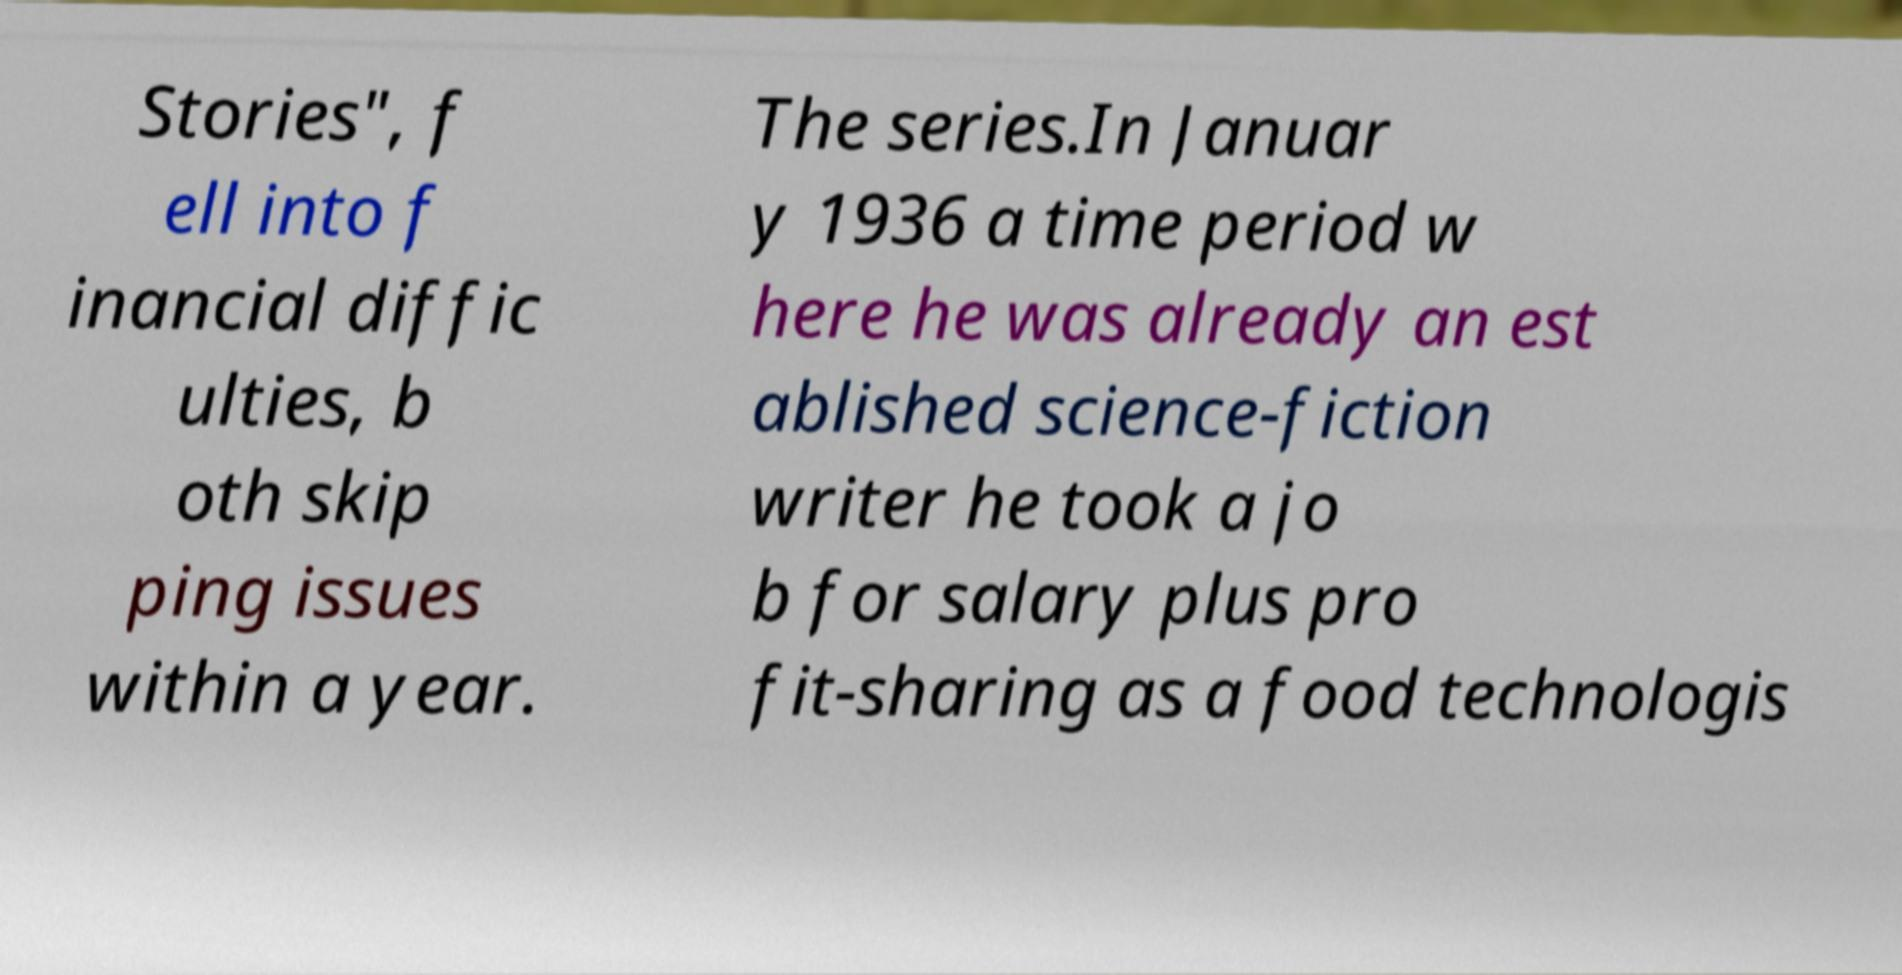Please read and relay the text visible in this image. What does it say? Stories", f ell into f inancial diffic ulties, b oth skip ping issues within a year. The series.In Januar y 1936 a time period w here he was already an est ablished science-fiction writer he took a jo b for salary plus pro fit-sharing as a food technologis 